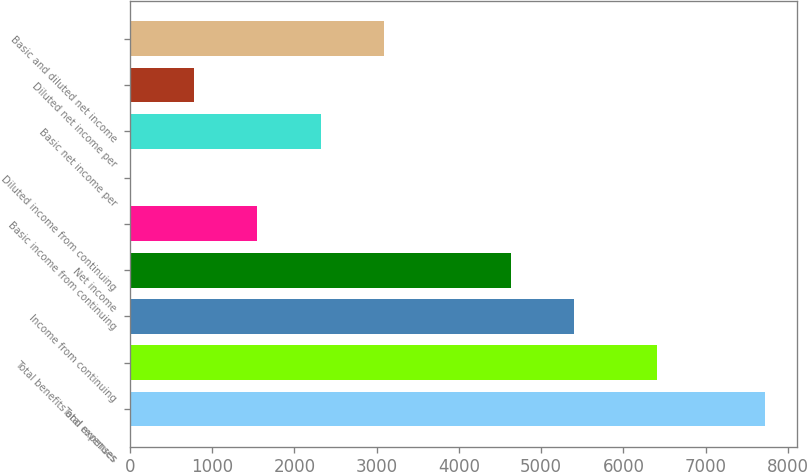Convert chart to OTSL. <chart><loc_0><loc_0><loc_500><loc_500><bar_chart><fcel>Total revenues<fcel>Total benefits and expenses<fcel>Income from continuing<fcel>Net income<fcel>Basic income from continuing<fcel>Diluted income from continuing<fcel>Basic net income per<fcel>Diluted net income per<fcel>Basic and diluted net income<nl><fcel>7721<fcel>6403<fcel>5405.14<fcel>4633.19<fcel>1545.39<fcel>1.49<fcel>2317.34<fcel>773.44<fcel>3089.29<nl></chart> 